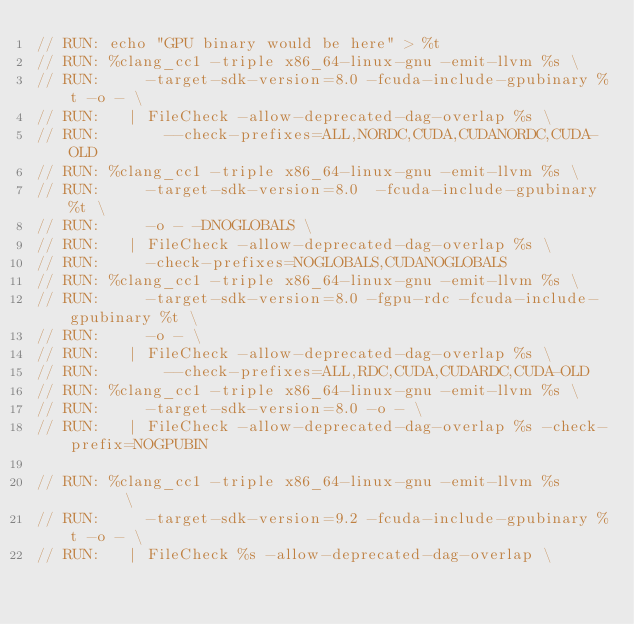<code> <loc_0><loc_0><loc_500><loc_500><_Cuda_>// RUN: echo "GPU binary would be here" > %t
// RUN: %clang_cc1 -triple x86_64-linux-gnu -emit-llvm %s \
// RUN:     -target-sdk-version=8.0 -fcuda-include-gpubinary %t -o - \
// RUN:   | FileCheck -allow-deprecated-dag-overlap %s \
// RUN:       --check-prefixes=ALL,NORDC,CUDA,CUDANORDC,CUDA-OLD
// RUN: %clang_cc1 -triple x86_64-linux-gnu -emit-llvm %s \
// RUN:     -target-sdk-version=8.0  -fcuda-include-gpubinary %t \
// RUN:     -o - -DNOGLOBALS \
// RUN:   | FileCheck -allow-deprecated-dag-overlap %s \
// RUN:     -check-prefixes=NOGLOBALS,CUDANOGLOBALS
// RUN: %clang_cc1 -triple x86_64-linux-gnu -emit-llvm %s \
// RUN:     -target-sdk-version=8.0 -fgpu-rdc -fcuda-include-gpubinary %t \
// RUN:     -o - \
// RUN:   | FileCheck -allow-deprecated-dag-overlap %s \
// RUN:       --check-prefixes=ALL,RDC,CUDA,CUDARDC,CUDA-OLD
// RUN: %clang_cc1 -triple x86_64-linux-gnu -emit-llvm %s \
// RUN:     -target-sdk-version=8.0 -o - \
// RUN:   | FileCheck -allow-deprecated-dag-overlap %s -check-prefix=NOGPUBIN

// RUN: %clang_cc1 -triple x86_64-linux-gnu -emit-llvm %s       \
// RUN:     -target-sdk-version=9.2 -fcuda-include-gpubinary %t -o - \
// RUN:   | FileCheck %s -allow-deprecated-dag-overlap \</code> 